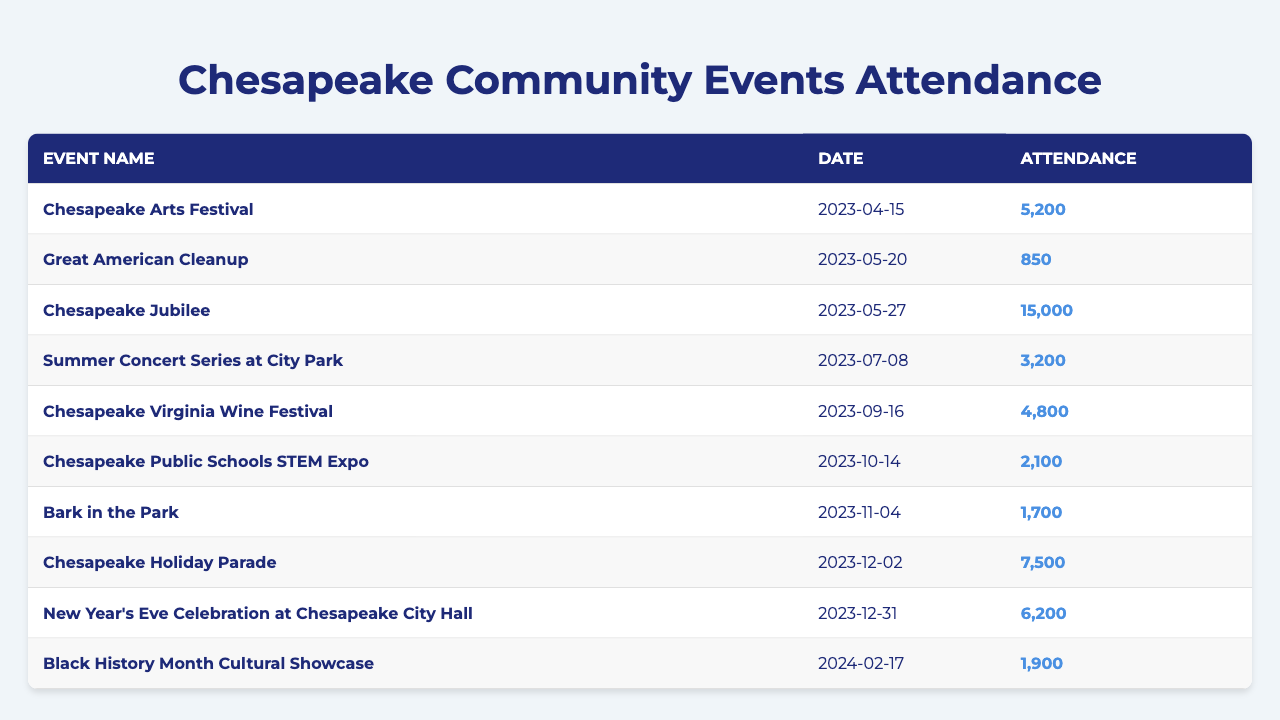What was the highest attendance at a community event in Chesapeake? The event with the highest attendance is the Chesapeake Jubilee, which had 15,000 attendees. This is identified by scanning through the attendance numbers provided in the table.
Answer: 15,000 Which event had the lowest attendance? The event with the lowest attendance is the Great American Cleanup, with only 850 attendees. This can be found by comparing all attendance figures from the table.
Answer: 850 How many attendees were there at the Chesapeake Holiday Parade? The Chesapeake Holiday Parade had an attendance of 7,500, which is explicitly stated in the table under the attendance column for that event.
Answer: 7,500 What is the total attendance for all events listed? To find the total attendance, sum all the attendance numbers: 5200 + 850 + 15000 + 3200 + 4800 + 2100 + 1700 + 7500 + 6200 = 37,550. The total is a result of adding each number together sequentially.
Answer: 37,550 Is the attendance for the New Year's Eve Celebration higher than the Chesapeake Arts Festival? The New Year's Eve Celebration had 6,200 attendees, while the Chesapeake Arts Festival had 5,200 attendees. Since 6,200 is greater than 5,200, this statement is true.
Answer: Yes What is the average attendance for the events in the table? To find the average, calculate the total attendance (37,550) and divide it by the number of events (9). The average is 37,550 / 9 = 4,172.22, which rounds to 4,172 when considering whole attendees.
Answer: 4,172 How many events had an attendance of over 5,000? The events with an attendance over 5,000 are the Chesapeake Arts Festival (5,200), Chesapeake Jubilee (15,000), Chesapeake Holiday Parade (7,500), and New Year's Eve Celebration (6,200). In total, there are four such events.
Answer: 4 What was the total attendance of events occurring in the summer months (June to August)? In the summer, the only listed event is the Summer Concert Series at City Park with 3,200 attendees. The total attendance for summer months is this single event's attendance figure.
Answer: 3,200 Is there a trend indicating a growth in attendance numbers throughout the year? To assess this, compare attendance figures sequentially: April (5,200), May (850 + 15,000), July (3,200), September (4,800), October (2,100), November (1,700), December (7,500), and December 31 (6,200). There is a notable spike in May and a fluctuating trend but no clear growth.
Answer: No Which month had the highest attendance event? May had the highest attendance event, the Chesapeake Jubilee, with 15,000 attendees. This is determined by checking each month’s highest attendance recorded in the events listed.
Answer: May 